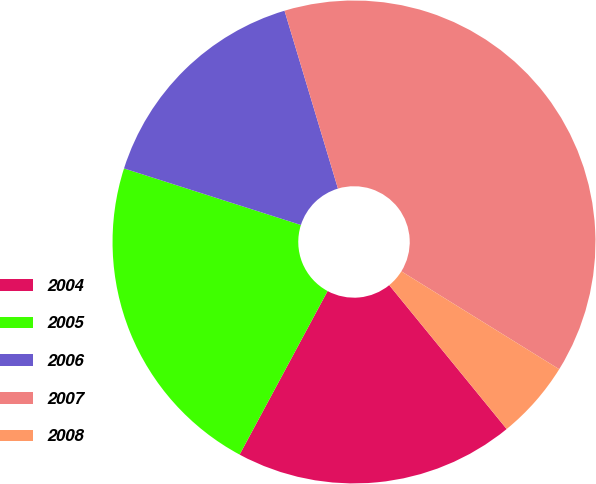Convert chart to OTSL. <chart><loc_0><loc_0><loc_500><loc_500><pie_chart><fcel>2004<fcel>2005<fcel>2006<fcel>2007<fcel>2008<nl><fcel>18.75%<fcel>22.07%<fcel>15.43%<fcel>38.48%<fcel>5.27%<nl></chart> 